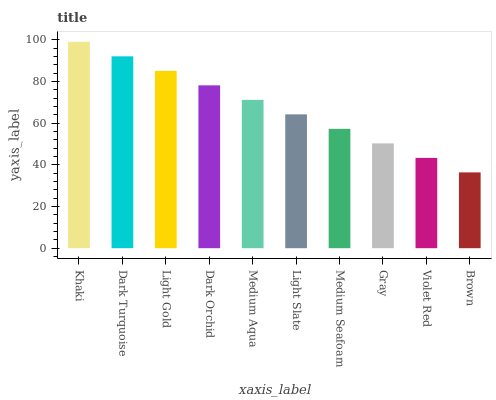Is Dark Turquoise the minimum?
Answer yes or no. No. Is Dark Turquoise the maximum?
Answer yes or no. No. Is Khaki greater than Dark Turquoise?
Answer yes or no. Yes. Is Dark Turquoise less than Khaki?
Answer yes or no. Yes. Is Dark Turquoise greater than Khaki?
Answer yes or no. No. Is Khaki less than Dark Turquoise?
Answer yes or no. No. Is Medium Aqua the high median?
Answer yes or no. Yes. Is Light Slate the low median?
Answer yes or no. Yes. Is Medium Seafoam the high median?
Answer yes or no. No. Is Brown the low median?
Answer yes or no. No. 